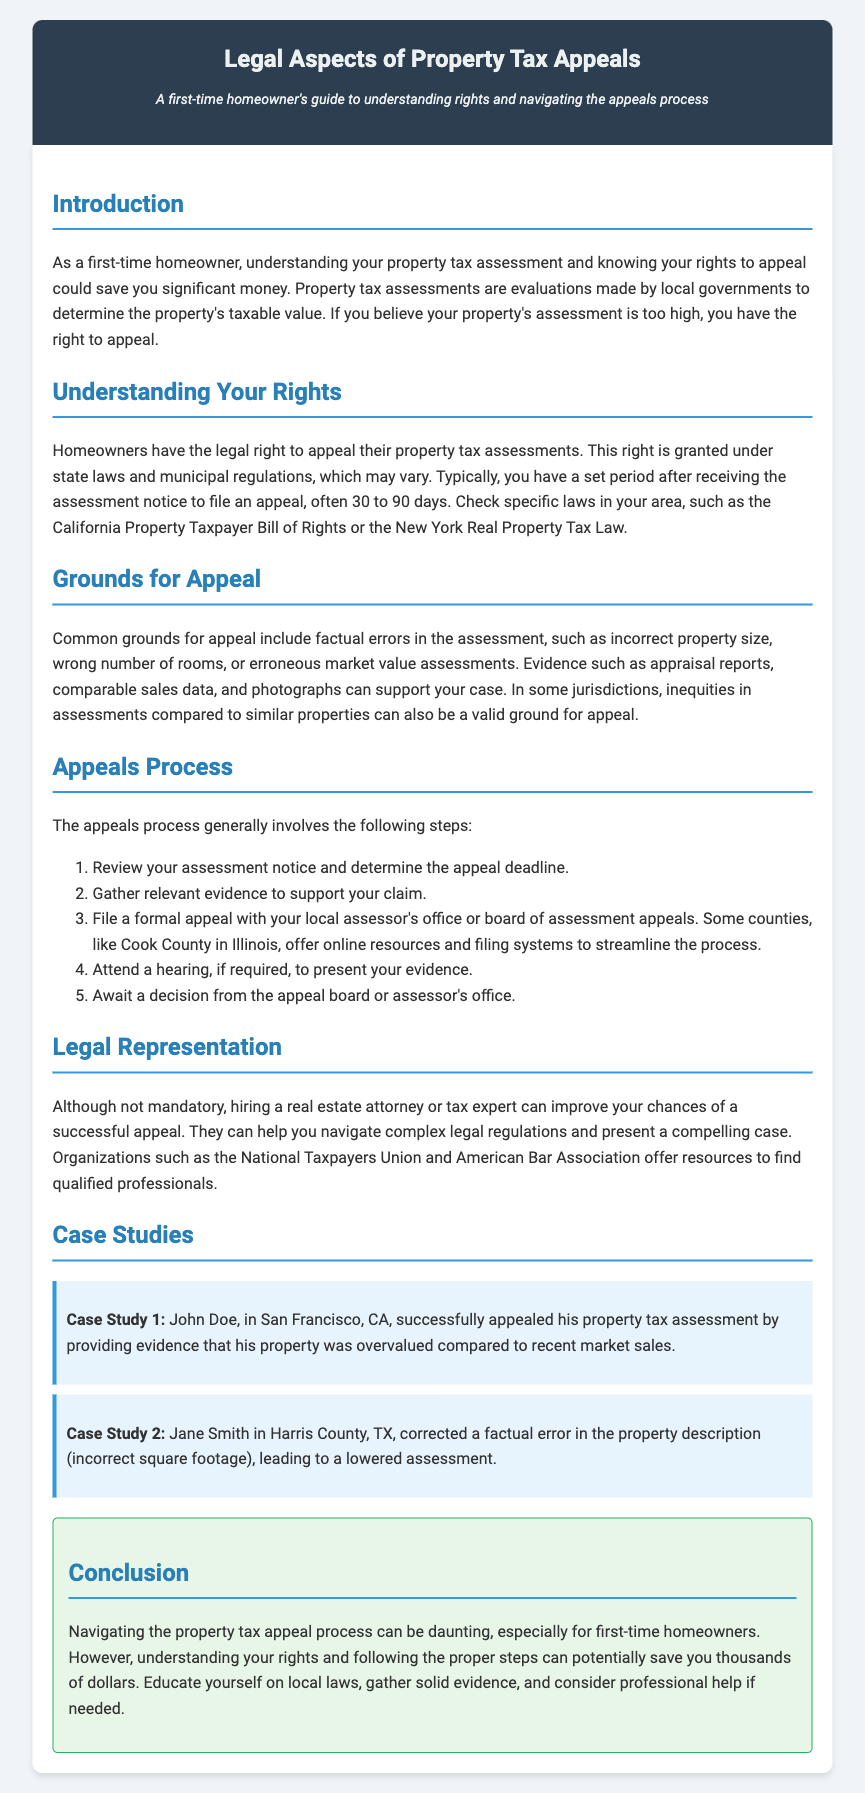What is the main purpose of this guide? The guide is aimed at helping first-time homeowners understand their rights and navigate the property tax appeals process.
Answer: Understanding rights and navigating the appeals process What is the typical timeframe to file an appeal after receiving the assessment notice? The document states that homeowners often have a set period after receiving the assessment notice, typically 30 to 90 days, to file an appeal.
Answer: 30 to 90 days What is one common ground for appeal mentioned in the document? The document lists factual errors in the assessment, such as incorrect property size, as a common ground for appeal.
Answer: Factual errors Which organization can assist in finding qualified professionals for legal representation? The document mentions the National Taxpayers Union as an organization that offers resources to find qualified professionals.
Answer: National Taxpayers Union What is the first step in the appeals process? The first step in the appeals process mentioned is to review your assessment notice and determine the appeal deadline.
Answer: Review your assessment notice How many case studies are included in the document? The document provides a total of two case studies to illustrate successful property tax appeals.
Answer: Two case studies 